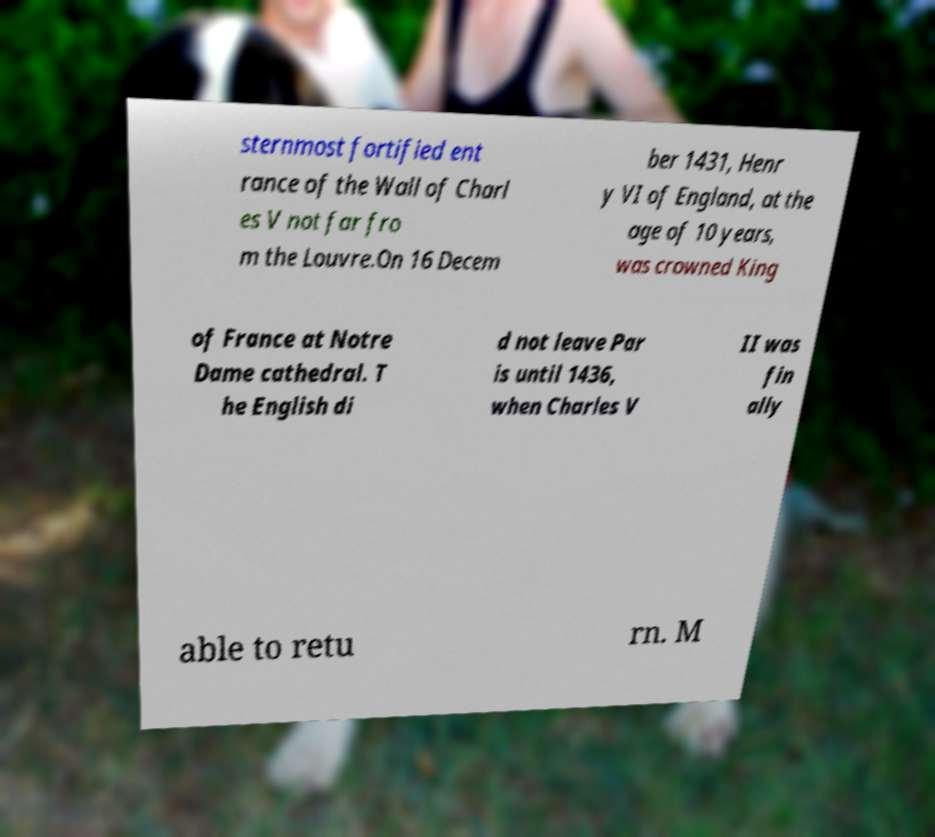Please identify and transcribe the text found in this image. sternmost fortified ent rance of the Wall of Charl es V not far fro m the Louvre.On 16 Decem ber 1431, Henr y VI of England, at the age of 10 years, was crowned King of France at Notre Dame cathedral. T he English di d not leave Par is until 1436, when Charles V II was fin ally able to retu rn. M 